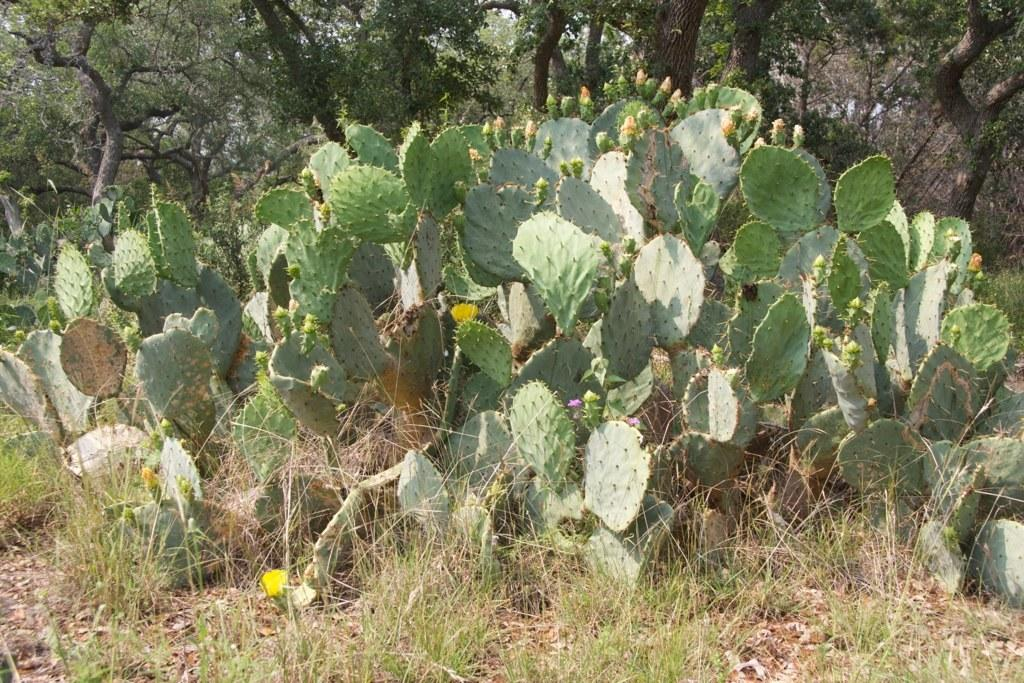What type of vegetation can be seen in the image? There are plants and grass in the image. What can be seen in the background of the image? There are trees in the background of the image. What type of creature is interacting with the plants in the image? There is no creature present in the image; it only features plants, grass, and trees. What role does the cabbage play in the image? There is no cabbage present in the image. 